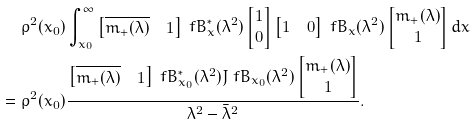<formula> <loc_0><loc_0><loc_500><loc_500>\rho ^ { 2 } ( x _ { 0 } ) & \int _ { x _ { 0 } } ^ { \infty } \begin{bmatrix} \overline { m _ { + } ( \lambda ) } & 1 \end{bmatrix} \ f B ^ { * } _ { x } ( \lambda ^ { 2 } ) \begin{bmatrix} 1 \\ 0 \end{bmatrix} \begin{bmatrix} 1 & 0 \end{bmatrix} \ f B _ { x } ( \lambda ^ { 2 } ) \begin{bmatrix} m _ { + } ( \lambda ) \\ 1 \end{bmatrix} { d x } \\ = \rho ^ { 2 } ( x _ { 0 } ) & \frac { \begin{bmatrix} \overline { m _ { + } ( \lambda ) } & 1 \end{bmatrix} \ f B ^ { * } _ { x _ { 0 } } ( \lambda ^ { 2 } ) J \ f B _ { x _ { 0 } } ( \lambda ^ { 2 } ) \begin{bmatrix} { m _ { + } ( \lambda ) } \\ 1 \end{bmatrix} } { \lambda ^ { 2 } - \bar { \lambda } ^ { 2 } } .</formula> 